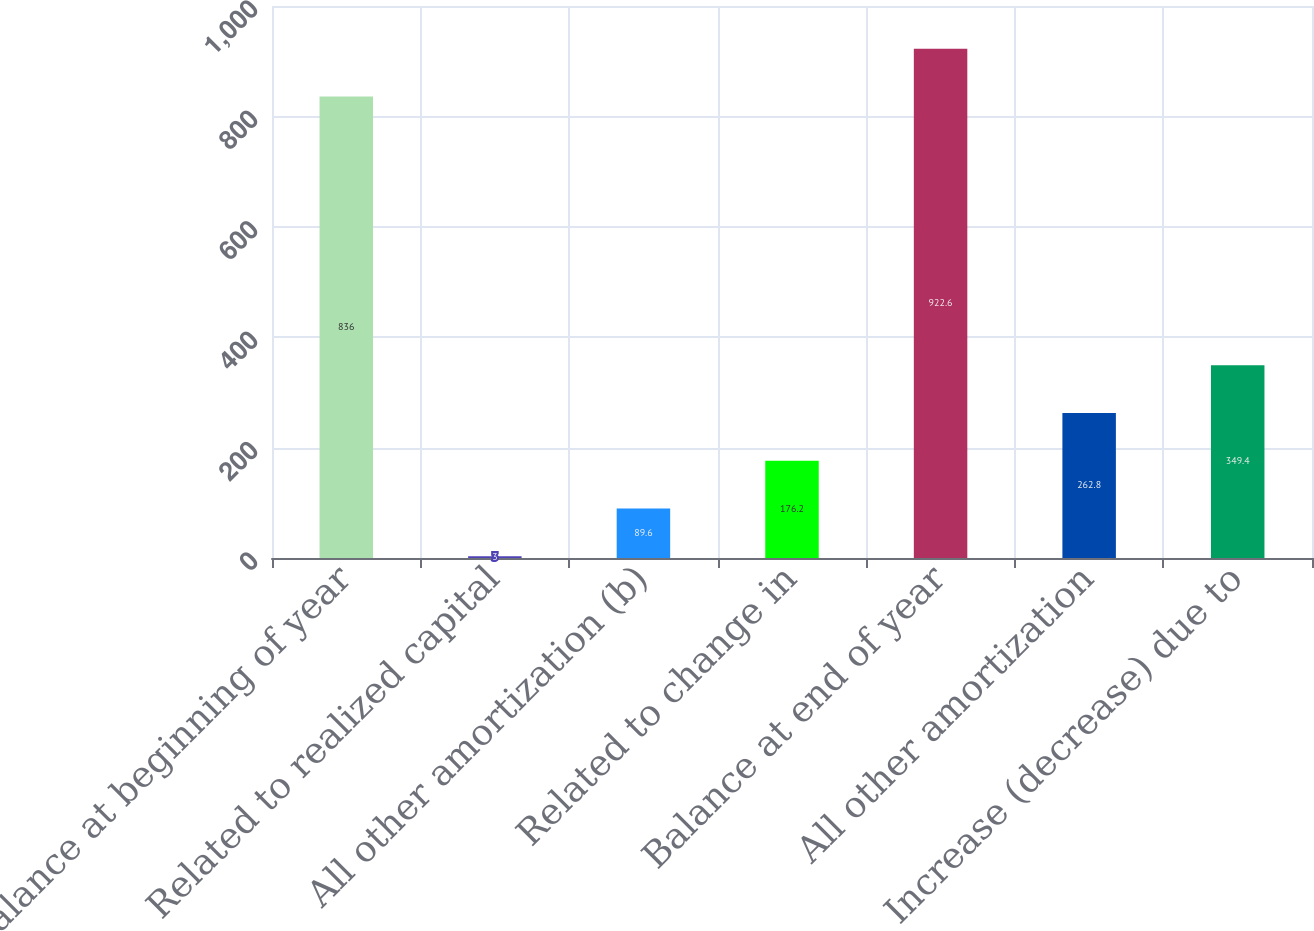Convert chart to OTSL. <chart><loc_0><loc_0><loc_500><loc_500><bar_chart><fcel>Balance at beginning of year<fcel>Related to realized capital<fcel>All other amortization (b)<fcel>Related to change in<fcel>Balance at end of year<fcel>All other amortization<fcel>Increase (decrease) due to<nl><fcel>836<fcel>3<fcel>89.6<fcel>176.2<fcel>922.6<fcel>262.8<fcel>349.4<nl></chart> 